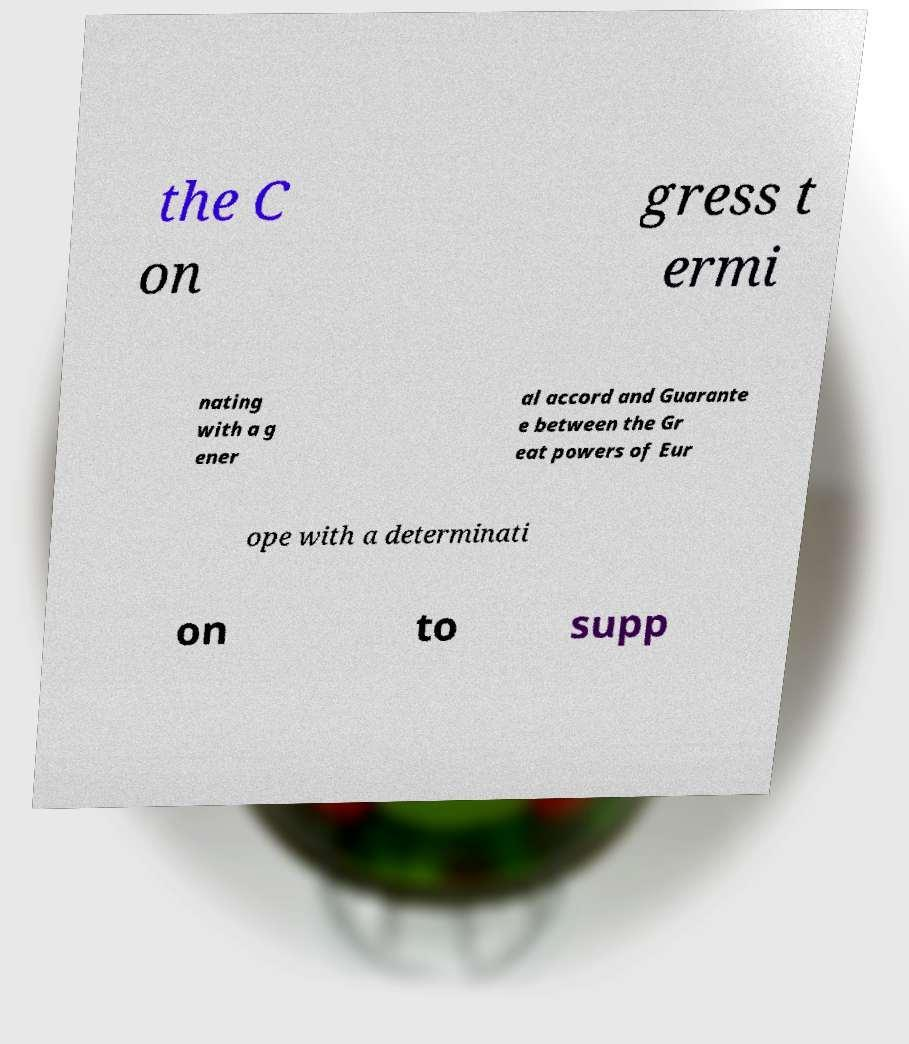Can you accurately transcribe the text from the provided image for me? the C on gress t ermi nating with a g ener al accord and Guarante e between the Gr eat powers of Eur ope with a determinati on to supp 